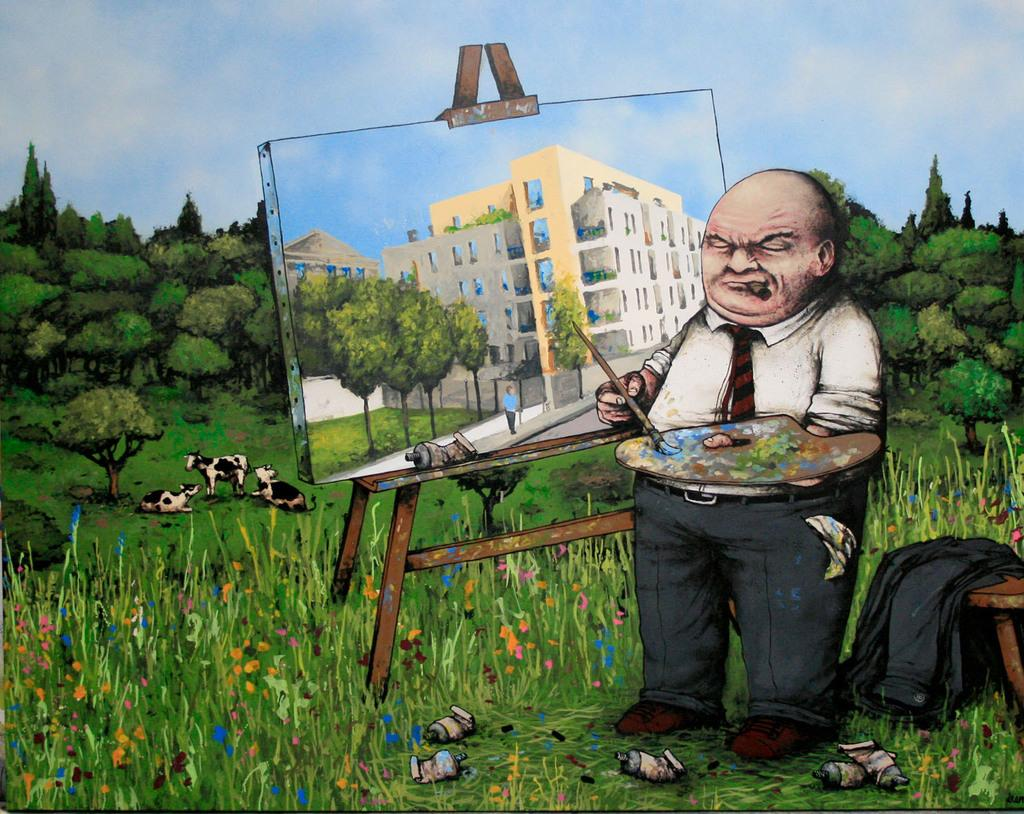What is the main subject of the image? The image contains a painting. What elements are included in the painting? The painting includes plants, insects, animals, grass, trees, sky, a man holding a brush, a board, and a building on the board. Can you describe the setting of the painting? The painting depicts a natural environment with plants, insects, animals, grass, trees, and sky. There is also a man holding a brush, suggesting he might be an artist. The board with a building on it adds an architectural element to the scene. How does the man in the painting grade the insects? There is no indication in the painting that the man is grading insects, as the painting primarily focuses on the natural environment and the man holding a brush. 